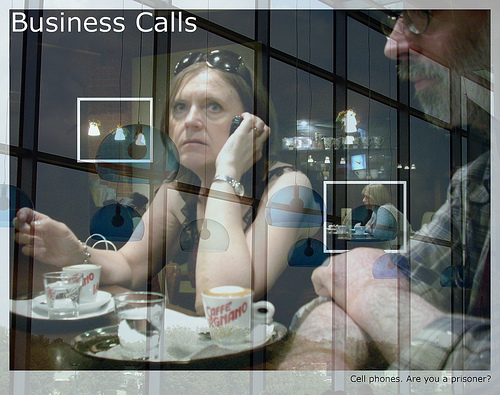Is the plate in the top part or in the bottom of the image? The plate is located in the bottom part of the image. 